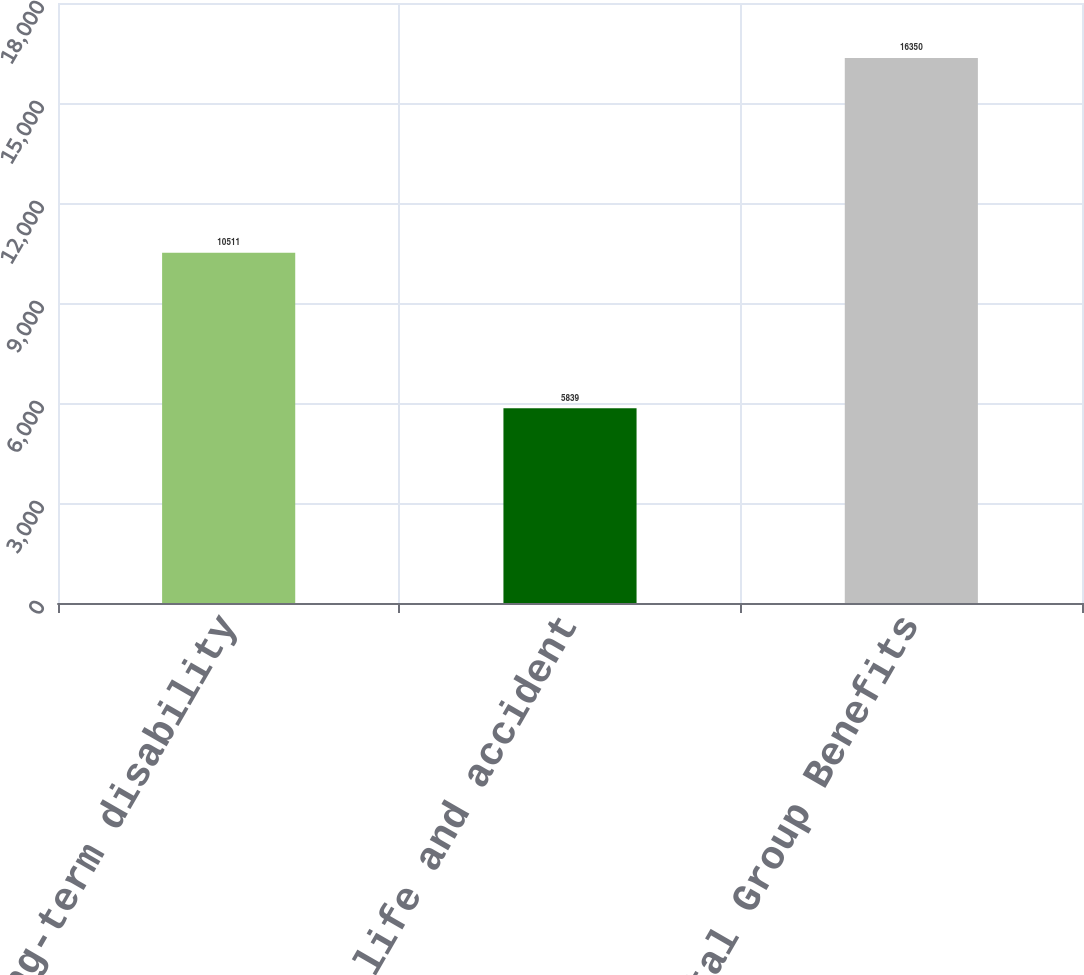Convert chart to OTSL. <chart><loc_0><loc_0><loc_500><loc_500><bar_chart><fcel>Group long-term disability<fcel>Group life and accident<fcel>Total Group Benefits<nl><fcel>10511<fcel>5839<fcel>16350<nl></chart> 